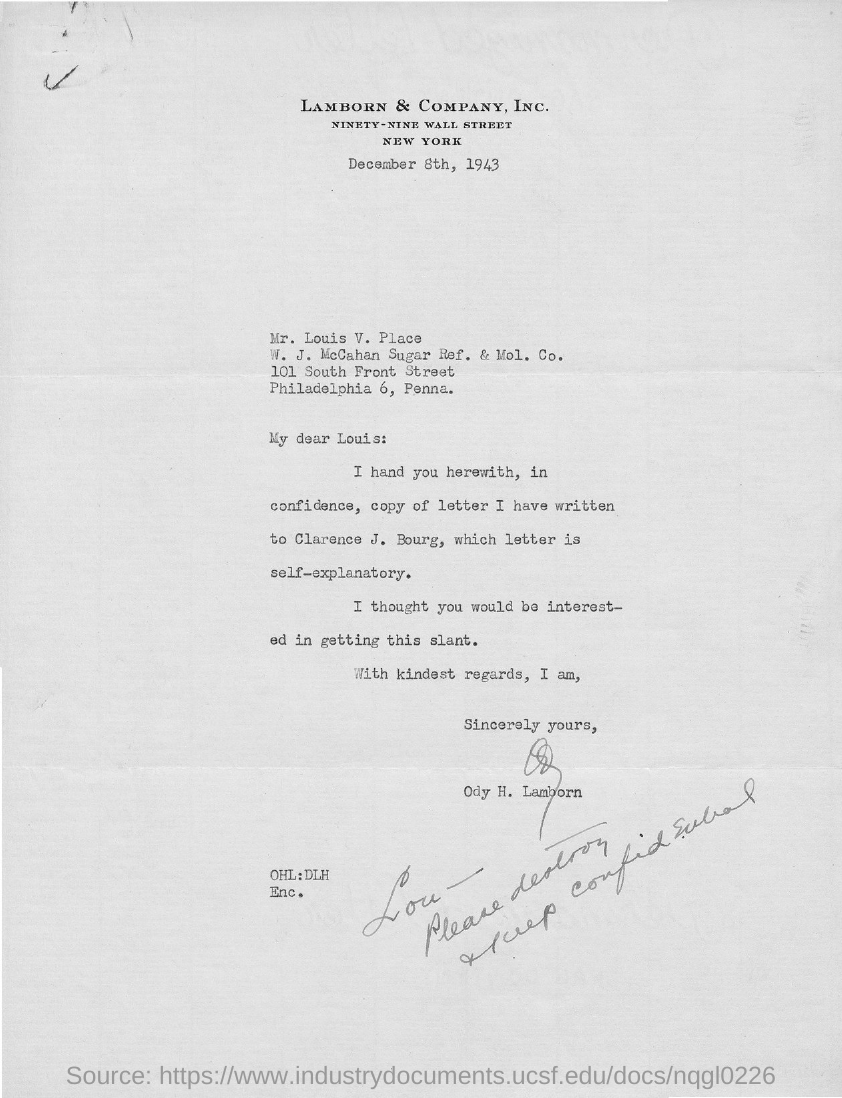Mention a couple of crucial points in this snapshot. The letter is from ODY H. LAMBORN. The document indicates that the date is December 8th, 1943. The letter is addressed to "To Whom is this letter addressed to? LOUIS. 